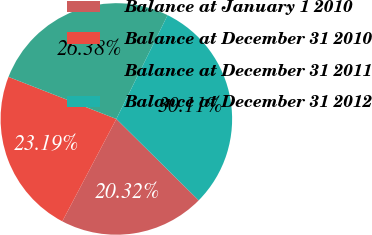Convert chart. <chart><loc_0><loc_0><loc_500><loc_500><pie_chart><fcel>Balance at January 1 2010<fcel>Balance at December 31 2010<fcel>Balance at December 31 2011<fcel>Balance at December 31 2012<nl><fcel>20.32%<fcel>23.19%<fcel>26.38%<fcel>30.11%<nl></chart> 